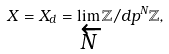Convert formula to latex. <formula><loc_0><loc_0><loc_500><loc_500>X = X _ { d } = \lim _ { \overleftarrow { N } } \mathbb { Z } / d p ^ { N } \mathbb { Z } ,</formula> 